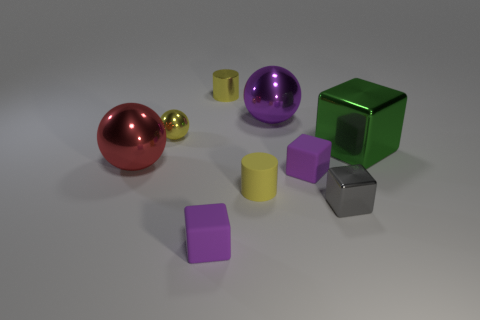There is a thing that is both right of the small metallic cylinder and behind the yellow metallic sphere; what color is it?
Make the answer very short. Purple. How many small objects are either yellow objects or purple things?
Offer a terse response. 5. There is another metallic object that is the same shape as the green metallic object; what size is it?
Provide a succinct answer. Small. What is the shape of the big green shiny object?
Offer a terse response. Cube. Is the big red thing made of the same material as the green object behind the small gray shiny cube?
Provide a succinct answer. Yes. What number of shiny objects are either objects or small cubes?
Ensure brevity in your answer.  6. There is a purple cube that is left of the large purple metallic sphere; what is its size?
Ensure brevity in your answer.  Small. What size is the cylinder that is made of the same material as the gray cube?
Provide a succinct answer. Small. How many cylinders are the same color as the tiny metallic sphere?
Provide a short and direct response. 2. Are any big brown cubes visible?
Keep it short and to the point. No. 